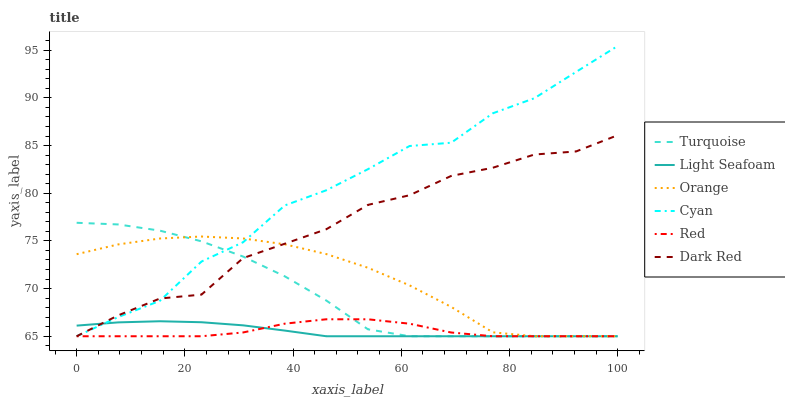Does Light Seafoam have the minimum area under the curve?
Answer yes or no. Yes. Does Cyan have the maximum area under the curve?
Answer yes or no. Yes. Does Dark Red have the minimum area under the curve?
Answer yes or no. No. Does Dark Red have the maximum area under the curve?
Answer yes or no. No. Is Light Seafoam the smoothest?
Answer yes or no. Yes. Is Cyan the roughest?
Answer yes or no. Yes. Is Dark Red the smoothest?
Answer yes or no. No. Is Dark Red the roughest?
Answer yes or no. No. Does Dark Red have the highest value?
Answer yes or no. No. 